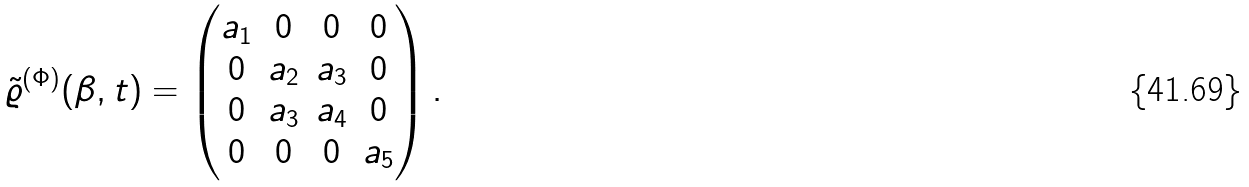<formula> <loc_0><loc_0><loc_500><loc_500>\tilde { \varrho } ^ { ( \Phi ) } ( \beta , t ) = \begin{pmatrix} a _ { 1 } & 0 & 0 & 0 \\ 0 & a _ { 2 } & a _ { 3 } & 0 \\ 0 & a _ { 3 } & a _ { 4 } & 0 \\ 0 & 0 & 0 & a _ { 5 } \\ \end{pmatrix} .</formula> 